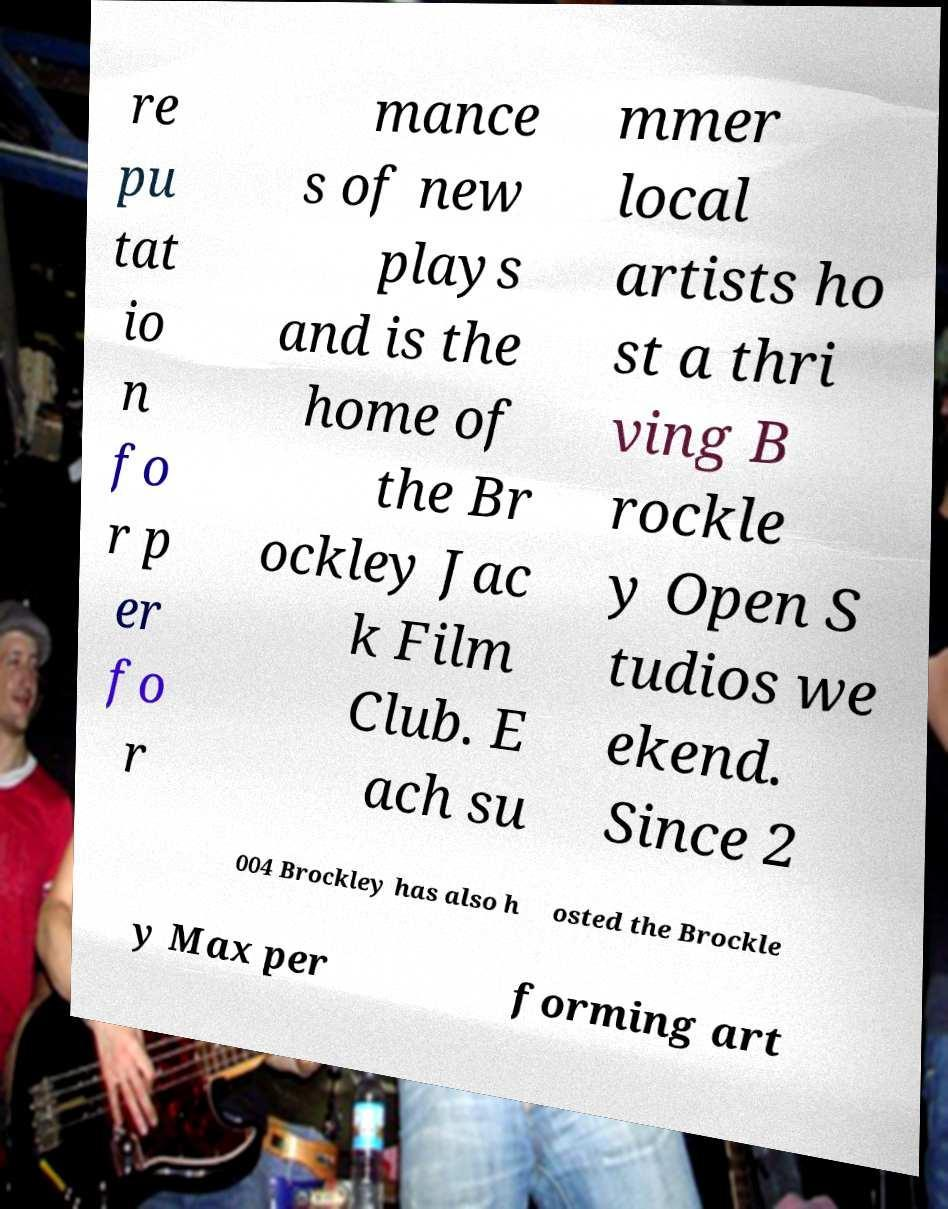There's text embedded in this image that I need extracted. Can you transcribe it verbatim? re pu tat io n fo r p er fo r mance s of new plays and is the home of the Br ockley Jac k Film Club. E ach su mmer local artists ho st a thri ving B rockle y Open S tudios we ekend. Since 2 004 Brockley has also h osted the Brockle y Max per forming art 